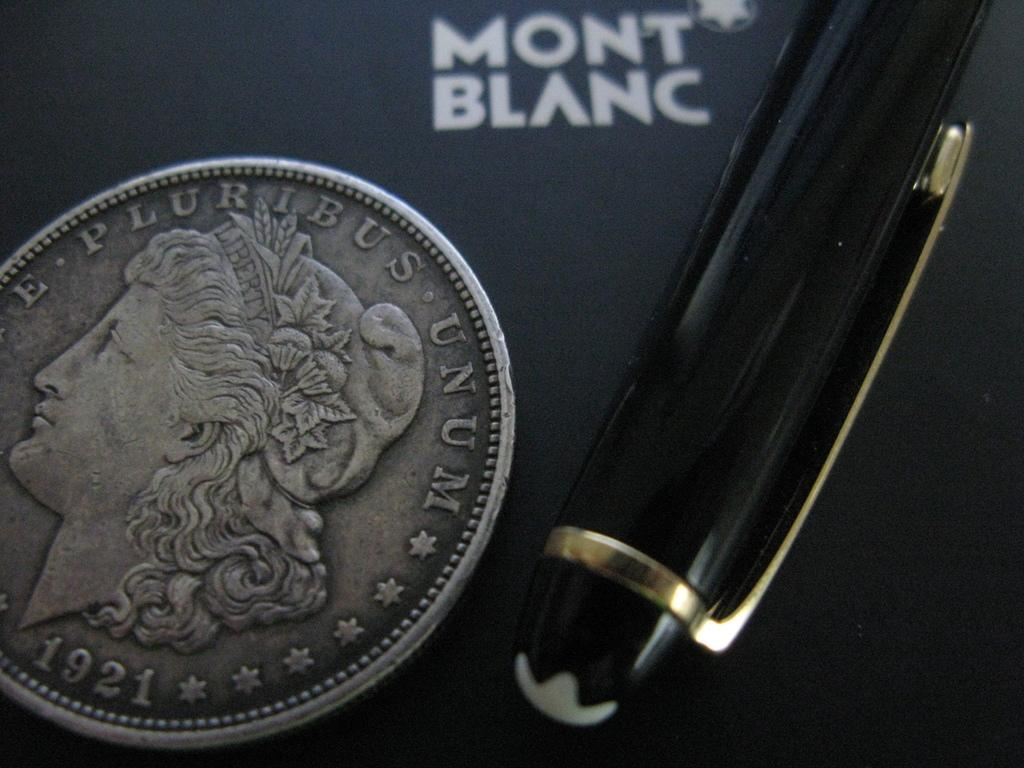<image>
Render a clear and concise summary of the photo. A coin from 1921 has the phrase "E Pluribus Unum" imprinted on it. 